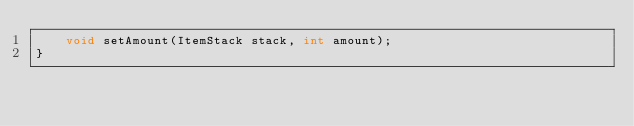<code> <loc_0><loc_0><loc_500><loc_500><_Java_>    void setAmount(ItemStack stack, int amount);
}
</code> 